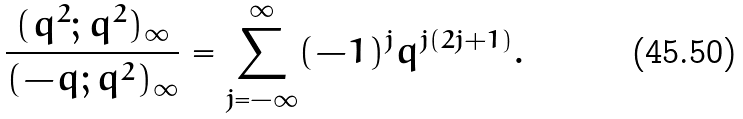<formula> <loc_0><loc_0><loc_500><loc_500>\frac { ( q ^ { 2 } ; q ^ { 2 } ) _ { \infty } } { ( - q ; q ^ { 2 } ) _ { \infty } } = \sum _ { j = - \infty } ^ { \infty } ( - 1 ) ^ { j } q ^ { j ( 2 j + 1 ) } .</formula> 